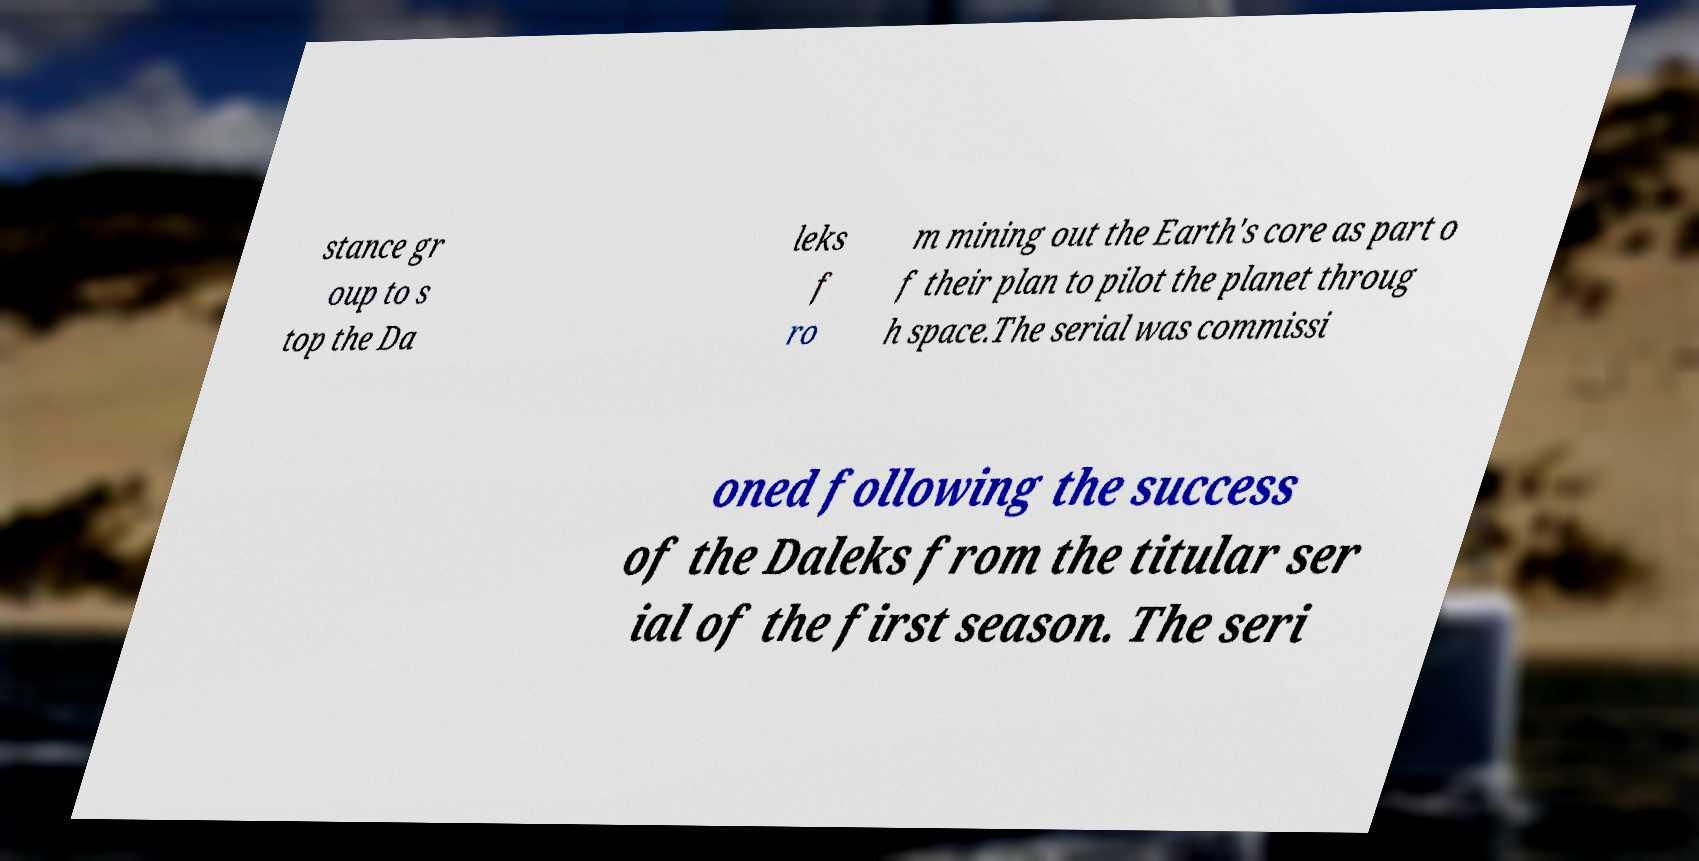Can you accurately transcribe the text from the provided image for me? stance gr oup to s top the Da leks f ro m mining out the Earth's core as part o f their plan to pilot the planet throug h space.The serial was commissi oned following the success of the Daleks from the titular ser ial of the first season. The seri 